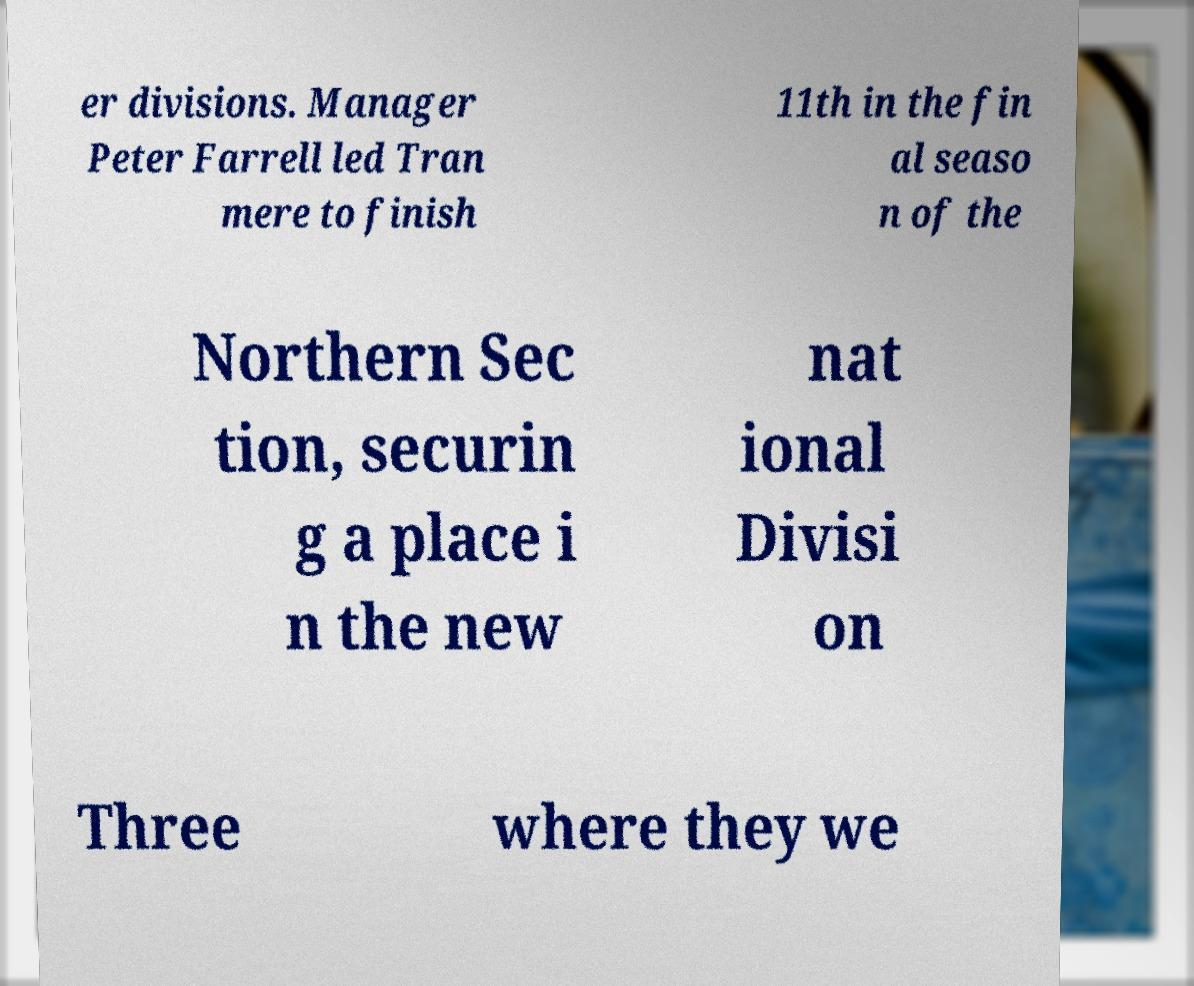Please read and relay the text visible in this image. What does it say? er divisions. Manager Peter Farrell led Tran mere to finish 11th in the fin al seaso n of the Northern Sec tion, securin g a place i n the new nat ional Divisi on Three where they we 